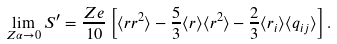<formula> <loc_0><loc_0><loc_500><loc_500>\lim _ { Z \alpha \rightarrow 0 } { S ^ { \prime } } = \frac { Z e } { 1 0 } \left [ \langle { r } r ^ { 2 } \rangle - \frac { 5 } { 3 } \langle { r } \rangle \langle r ^ { 2 } \rangle - \frac { 2 } { 3 } \langle r _ { i } \rangle \langle q _ { i j } \rangle \right ] .</formula> 